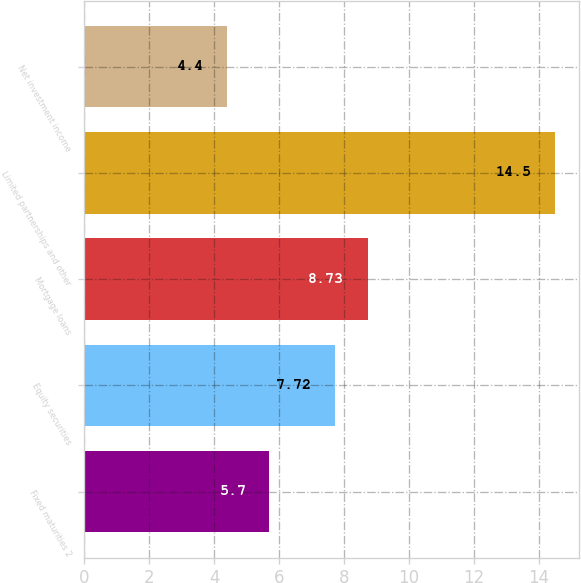Convert chart. <chart><loc_0><loc_0><loc_500><loc_500><bar_chart><fcel>Fixed maturities 2<fcel>Equity securities<fcel>Mortgage loans<fcel>Limited partnerships and other<fcel>Net investment income<nl><fcel>5.7<fcel>7.72<fcel>8.73<fcel>14.5<fcel>4.4<nl></chart> 